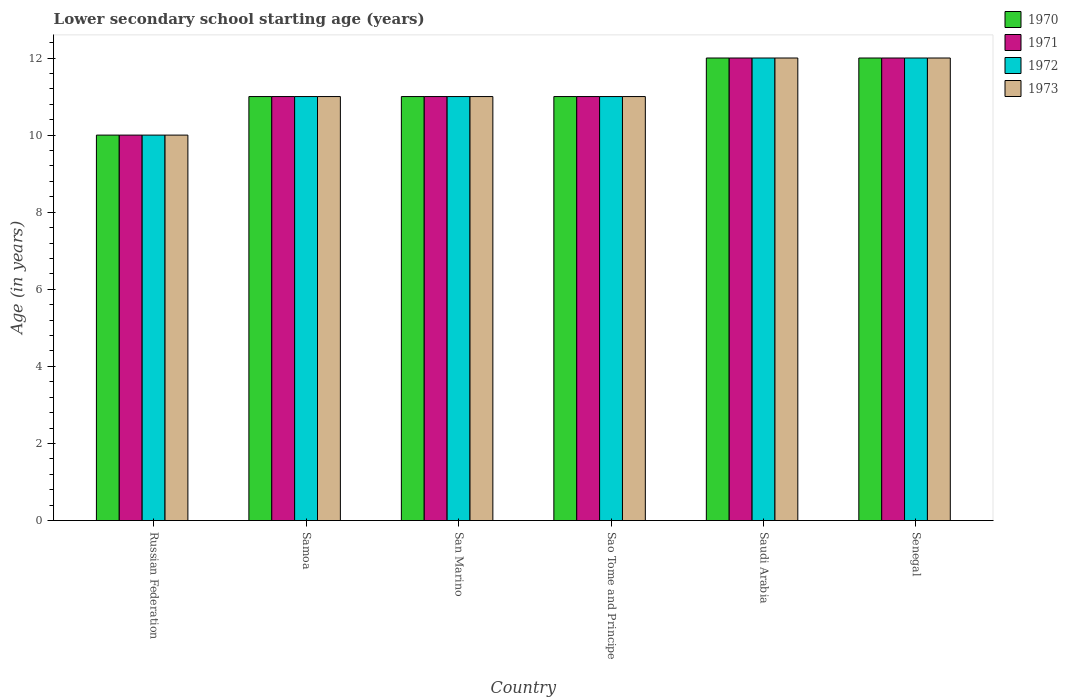How many groups of bars are there?
Your answer should be compact. 6. Are the number of bars per tick equal to the number of legend labels?
Your answer should be very brief. Yes. Are the number of bars on each tick of the X-axis equal?
Your answer should be compact. Yes. How many bars are there on the 2nd tick from the left?
Make the answer very short. 4. How many bars are there on the 1st tick from the right?
Ensure brevity in your answer.  4. What is the label of the 2nd group of bars from the left?
Provide a short and direct response. Samoa. In how many cases, is the number of bars for a given country not equal to the number of legend labels?
Ensure brevity in your answer.  0. What is the lower secondary school starting age of children in 1970 in Senegal?
Offer a terse response. 12. Across all countries, what is the minimum lower secondary school starting age of children in 1973?
Give a very brief answer. 10. In which country was the lower secondary school starting age of children in 1971 maximum?
Provide a succinct answer. Saudi Arabia. In which country was the lower secondary school starting age of children in 1970 minimum?
Your response must be concise. Russian Federation. What is the average lower secondary school starting age of children in 1972 per country?
Give a very brief answer. 11.17. In how many countries, is the lower secondary school starting age of children in 1972 greater than 6.8 years?
Offer a very short reply. 6. What is the ratio of the lower secondary school starting age of children in 1972 in Samoa to that in Sao Tome and Principe?
Your answer should be compact. 1. Is the lower secondary school starting age of children in 1970 in San Marino less than that in Saudi Arabia?
Make the answer very short. Yes. What is the difference between the highest and the second highest lower secondary school starting age of children in 1973?
Provide a succinct answer. -1. What is the difference between the highest and the lowest lower secondary school starting age of children in 1973?
Your response must be concise. 2. Is it the case that in every country, the sum of the lower secondary school starting age of children in 1971 and lower secondary school starting age of children in 1973 is greater than the sum of lower secondary school starting age of children in 1972 and lower secondary school starting age of children in 1970?
Your answer should be very brief. No. What does the 2nd bar from the left in Sao Tome and Principe represents?
Offer a terse response. 1971. What is the difference between two consecutive major ticks on the Y-axis?
Offer a terse response. 2. Does the graph contain any zero values?
Provide a short and direct response. No. How are the legend labels stacked?
Offer a very short reply. Vertical. What is the title of the graph?
Offer a terse response. Lower secondary school starting age (years). What is the label or title of the X-axis?
Offer a terse response. Country. What is the label or title of the Y-axis?
Ensure brevity in your answer.  Age (in years). What is the Age (in years) of 1970 in Russian Federation?
Your response must be concise. 10. What is the Age (in years) of 1970 in Samoa?
Keep it short and to the point. 11. What is the Age (in years) of 1972 in Samoa?
Your answer should be compact. 11. What is the Age (in years) of 1970 in San Marino?
Your answer should be very brief. 11. What is the Age (in years) of 1972 in San Marino?
Offer a terse response. 11. What is the Age (in years) in 1973 in San Marino?
Your answer should be compact. 11. What is the Age (in years) in 1970 in Sao Tome and Principe?
Make the answer very short. 11. What is the Age (in years) in 1971 in Sao Tome and Principe?
Provide a succinct answer. 11. What is the Age (in years) in 1972 in Sao Tome and Principe?
Offer a very short reply. 11. What is the Age (in years) of 1970 in Saudi Arabia?
Ensure brevity in your answer.  12. What is the Age (in years) of 1971 in Saudi Arabia?
Offer a terse response. 12. What is the Age (in years) in 1970 in Senegal?
Your answer should be compact. 12. What is the Age (in years) of 1971 in Senegal?
Your response must be concise. 12. What is the Age (in years) in 1972 in Senegal?
Give a very brief answer. 12. Across all countries, what is the maximum Age (in years) in 1970?
Offer a very short reply. 12. Across all countries, what is the maximum Age (in years) in 1972?
Provide a short and direct response. 12. Across all countries, what is the minimum Age (in years) in 1971?
Offer a very short reply. 10. What is the total Age (in years) of 1970 in the graph?
Your answer should be very brief. 67. What is the total Age (in years) in 1971 in the graph?
Make the answer very short. 67. What is the difference between the Age (in years) in 1970 in Russian Federation and that in Samoa?
Ensure brevity in your answer.  -1. What is the difference between the Age (in years) of 1972 in Russian Federation and that in Samoa?
Give a very brief answer. -1. What is the difference between the Age (in years) in 1973 in Russian Federation and that in Samoa?
Keep it short and to the point. -1. What is the difference between the Age (in years) in 1972 in Russian Federation and that in San Marino?
Offer a terse response. -1. What is the difference between the Age (in years) in 1970 in Russian Federation and that in Sao Tome and Principe?
Your answer should be very brief. -1. What is the difference between the Age (in years) in 1971 in Russian Federation and that in Saudi Arabia?
Offer a terse response. -2. What is the difference between the Age (in years) of 1972 in Russian Federation and that in Saudi Arabia?
Offer a terse response. -2. What is the difference between the Age (in years) of 1970 in Russian Federation and that in Senegal?
Make the answer very short. -2. What is the difference between the Age (in years) in 1971 in Samoa and that in San Marino?
Provide a short and direct response. 0. What is the difference between the Age (in years) of 1972 in Samoa and that in San Marino?
Make the answer very short. 0. What is the difference between the Age (in years) of 1972 in Samoa and that in Sao Tome and Principe?
Your response must be concise. 0. What is the difference between the Age (in years) in 1970 in Samoa and that in Saudi Arabia?
Your answer should be very brief. -1. What is the difference between the Age (in years) in 1971 in Samoa and that in Saudi Arabia?
Make the answer very short. -1. What is the difference between the Age (in years) in 1972 in Samoa and that in Saudi Arabia?
Your answer should be very brief. -1. What is the difference between the Age (in years) of 1971 in Samoa and that in Senegal?
Provide a short and direct response. -1. What is the difference between the Age (in years) in 1972 in Samoa and that in Senegal?
Offer a terse response. -1. What is the difference between the Age (in years) in 1973 in Samoa and that in Senegal?
Make the answer very short. -1. What is the difference between the Age (in years) in 1971 in San Marino and that in Sao Tome and Principe?
Provide a short and direct response. 0. What is the difference between the Age (in years) of 1973 in San Marino and that in Sao Tome and Principe?
Your answer should be compact. 0. What is the difference between the Age (in years) of 1971 in San Marino and that in Saudi Arabia?
Provide a short and direct response. -1. What is the difference between the Age (in years) in 1970 in San Marino and that in Senegal?
Give a very brief answer. -1. What is the difference between the Age (in years) in 1971 in San Marino and that in Senegal?
Your answer should be very brief. -1. What is the difference between the Age (in years) in 1973 in San Marino and that in Senegal?
Provide a short and direct response. -1. What is the difference between the Age (in years) of 1970 in Sao Tome and Principe and that in Senegal?
Offer a terse response. -1. What is the difference between the Age (in years) in 1971 in Sao Tome and Principe and that in Senegal?
Your answer should be very brief. -1. What is the difference between the Age (in years) of 1972 in Sao Tome and Principe and that in Senegal?
Offer a terse response. -1. What is the difference between the Age (in years) of 1970 in Saudi Arabia and that in Senegal?
Provide a short and direct response. 0. What is the difference between the Age (in years) of 1970 in Russian Federation and the Age (in years) of 1972 in Samoa?
Your response must be concise. -1. What is the difference between the Age (in years) of 1970 in Russian Federation and the Age (in years) of 1973 in Samoa?
Your answer should be compact. -1. What is the difference between the Age (in years) of 1972 in Russian Federation and the Age (in years) of 1973 in Samoa?
Your answer should be very brief. -1. What is the difference between the Age (in years) of 1970 in Russian Federation and the Age (in years) of 1971 in San Marino?
Your response must be concise. -1. What is the difference between the Age (in years) of 1970 in Russian Federation and the Age (in years) of 1973 in San Marino?
Your answer should be compact. -1. What is the difference between the Age (in years) in 1970 in Russian Federation and the Age (in years) in 1971 in Sao Tome and Principe?
Provide a succinct answer. -1. What is the difference between the Age (in years) of 1970 in Russian Federation and the Age (in years) of 1973 in Sao Tome and Principe?
Your answer should be compact. -1. What is the difference between the Age (in years) in 1971 in Russian Federation and the Age (in years) in 1973 in Sao Tome and Principe?
Give a very brief answer. -1. What is the difference between the Age (in years) in 1970 in Russian Federation and the Age (in years) in 1971 in Saudi Arabia?
Ensure brevity in your answer.  -2. What is the difference between the Age (in years) of 1970 in Russian Federation and the Age (in years) of 1972 in Saudi Arabia?
Offer a terse response. -2. What is the difference between the Age (in years) in 1971 in Russian Federation and the Age (in years) in 1972 in Saudi Arabia?
Provide a short and direct response. -2. What is the difference between the Age (in years) in 1971 in Russian Federation and the Age (in years) in 1973 in Saudi Arabia?
Keep it short and to the point. -2. What is the difference between the Age (in years) in 1970 in Russian Federation and the Age (in years) in 1971 in Senegal?
Provide a short and direct response. -2. What is the difference between the Age (in years) of 1970 in Russian Federation and the Age (in years) of 1972 in Senegal?
Your response must be concise. -2. What is the difference between the Age (in years) of 1972 in Russian Federation and the Age (in years) of 1973 in Senegal?
Keep it short and to the point. -2. What is the difference between the Age (in years) in 1970 in Samoa and the Age (in years) in 1972 in San Marino?
Your response must be concise. 0. What is the difference between the Age (in years) of 1970 in Samoa and the Age (in years) of 1973 in San Marino?
Your answer should be compact. 0. What is the difference between the Age (in years) in 1971 in Samoa and the Age (in years) in 1972 in San Marino?
Your answer should be compact. 0. What is the difference between the Age (in years) of 1970 in Samoa and the Age (in years) of 1971 in Sao Tome and Principe?
Offer a terse response. 0. What is the difference between the Age (in years) of 1972 in Samoa and the Age (in years) of 1973 in Saudi Arabia?
Your answer should be very brief. -1. What is the difference between the Age (in years) of 1970 in Samoa and the Age (in years) of 1972 in Senegal?
Give a very brief answer. -1. What is the difference between the Age (in years) of 1971 in Samoa and the Age (in years) of 1973 in Senegal?
Your response must be concise. -1. What is the difference between the Age (in years) of 1970 in San Marino and the Age (in years) of 1971 in Sao Tome and Principe?
Your response must be concise. 0. What is the difference between the Age (in years) in 1970 in San Marino and the Age (in years) in 1972 in Sao Tome and Principe?
Ensure brevity in your answer.  0. What is the difference between the Age (in years) of 1970 in San Marino and the Age (in years) of 1973 in Sao Tome and Principe?
Make the answer very short. 0. What is the difference between the Age (in years) of 1971 in San Marino and the Age (in years) of 1972 in Sao Tome and Principe?
Offer a terse response. 0. What is the difference between the Age (in years) in 1972 in San Marino and the Age (in years) in 1973 in Sao Tome and Principe?
Offer a very short reply. 0. What is the difference between the Age (in years) of 1970 in San Marino and the Age (in years) of 1971 in Saudi Arabia?
Keep it short and to the point. -1. What is the difference between the Age (in years) of 1970 in San Marino and the Age (in years) of 1972 in Saudi Arabia?
Keep it short and to the point. -1. What is the difference between the Age (in years) of 1970 in San Marino and the Age (in years) of 1973 in Saudi Arabia?
Provide a succinct answer. -1. What is the difference between the Age (in years) of 1970 in San Marino and the Age (in years) of 1971 in Senegal?
Your answer should be very brief. -1. What is the difference between the Age (in years) of 1970 in San Marino and the Age (in years) of 1972 in Senegal?
Your response must be concise. -1. What is the difference between the Age (in years) of 1971 in San Marino and the Age (in years) of 1973 in Senegal?
Your response must be concise. -1. What is the difference between the Age (in years) of 1972 in San Marino and the Age (in years) of 1973 in Senegal?
Ensure brevity in your answer.  -1. What is the difference between the Age (in years) of 1970 in Sao Tome and Principe and the Age (in years) of 1971 in Saudi Arabia?
Give a very brief answer. -1. What is the difference between the Age (in years) of 1970 in Sao Tome and Principe and the Age (in years) of 1972 in Saudi Arabia?
Your response must be concise. -1. What is the difference between the Age (in years) in 1970 in Sao Tome and Principe and the Age (in years) in 1973 in Saudi Arabia?
Your answer should be very brief. -1. What is the difference between the Age (in years) in 1971 in Sao Tome and Principe and the Age (in years) in 1972 in Saudi Arabia?
Provide a short and direct response. -1. What is the difference between the Age (in years) of 1971 in Sao Tome and Principe and the Age (in years) of 1973 in Saudi Arabia?
Provide a succinct answer. -1. What is the difference between the Age (in years) of 1970 in Sao Tome and Principe and the Age (in years) of 1971 in Senegal?
Offer a terse response. -1. What is the difference between the Age (in years) in 1970 in Sao Tome and Principe and the Age (in years) in 1973 in Senegal?
Your response must be concise. -1. What is the difference between the Age (in years) of 1970 in Saudi Arabia and the Age (in years) of 1972 in Senegal?
Provide a succinct answer. 0. What is the difference between the Age (in years) of 1971 in Saudi Arabia and the Age (in years) of 1972 in Senegal?
Provide a succinct answer. 0. What is the difference between the Age (in years) in 1972 in Saudi Arabia and the Age (in years) in 1973 in Senegal?
Your answer should be compact. 0. What is the average Age (in years) in 1970 per country?
Your answer should be very brief. 11.17. What is the average Age (in years) in 1971 per country?
Provide a short and direct response. 11.17. What is the average Age (in years) of 1972 per country?
Provide a short and direct response. 11.17. What is the average Age (in years) in 1973 per country?
Offer a very short reply. 11.17. What is the difference between the Age (in years) of 1972 and Age (in years) of 1973 in Russian Federation?
Keep it short and to the point. 0. What is the difference between the Age (in years) in 1970 and Age (in years) in 1973 in Samoa?
Your response must be concise. 0. What is the difference between the Age (in years) in 1970 and Age (in years) in 1971 in San Marino?
Make the answer very short. 0. What is the difference between the Age (in years) in 1970 and Age (in years) in 1972 in San Marino?
Your response must be concise. 0. What is the difference between the Age (in years) of 1970 and Age (in years) of 1973 in San Marino?
Your response must be concise. 0. What is the difference between the Age (in years) of 1971 and Age (in years) of 1972 in San Marino?
Offer a terse response. 0. What is the difference between the Age (in years) in 1972 and Age (in years) in 1973 in San Marino?
Your answer should be compact. 0. What is the difference between the Age (in years) in 1970 and Age (in years) in 1971 in Sao Tome and Principe?
Ensure brevity in your answer.  0. What is the difference between the Age (in years) in 1970 and Age (in years) in 1972 in Sao Tome and Principe?
Give a very brief answer. 0. What is the difference between the Age (in years) of 1972 and Age (in years) of 1973 in Sao Tome and Principe?
Keep it short and to the point. 0. What is the difference between the Age (in years) of 1970 and Age (in years) of 1971 in Saudi Arabia?
Provide a short and direct response. 0. What is the difference between the Age (in years) of 1970 and Age (in years) of 1972 in Saudi Arabia?
Offer a terse response. 0. What is the difference between the Age (in years) in 1970 and Age (in years) in 1973 in Saudi Arabia?
Your answer should be compact. 0. What is the difference between the Age (in years) in 1971 and Age (in years) in 1972 in Saudi Arabia?
Offer a very short reply. 0. What is the difference between the Age (in years) in 1972 and Age (in years) in 1973 in Saudi Arabia?
Ensure brevity in your answer.  0. What is the difference between the Age (in years) in 1970 and Age (in years) in 1971 in Senegal?
Ensure brevity in your answer.  0. What is the difference between the Age (in years) of 1970 and Age (in years) of 1972 in Senegal?
Provide a short and direct response. 0. What is the difference between the Age (in years) of 1971 and Age (in years) of 1972 in Senegal?
Ensure brevity in your answer.  0. What is the difference between the Age (in years) of 1971 and Age (in years) of 1973 in Senegal?
Ensure brevity in your answer.  0. What is the difference between the Age (in years) in 1972 and Age (in years) in 1973 in Senegal?
Give a very brief answer. 0. What is the ratio of the Age (in years) of 1970 in Russian Federation to that in Samoa?
Your answer should be very brief. 0.91. What is the ratio of the Age (in years) in 1972 in Russian Federation to that in Samoa?
Make the answer very short. 0.91. What is the ratio of the Age (in years) of 1970 in Russian Federation to that in San Marino?
Your answer should be very brief. 0.91. What is the ratio of the Age (in years) in 1971 in Russian Federation to that in San Marino?
Keep it short and to the point. 0.91. What is the ratio of the Age (in years) of 1970 in Russian Federation to that in Sao Tome and Principe?
Your answer should be compact. 0.91. What is the ratio of the Age (in years) in 1973 in Russian Federation to that in Sao Tome and Principe?
Provide a succinct answer. 0.91. What is the ratio of the Age (in years) in 1971 in Russian Federation to that in Saudi Arabia?
Offer a terse response. 0.83. What is the ratio of the Age (in years) in 1973 in Russian Federation to that in Saudi Arabia?
Offer a terse response. 0.83. What is the ratio of the Age (in years) in 1971 in Russian Federation to that in Senegal?
Ensure brevity in your answer.  0.83. What is the ratio of the Age (in years) of 1972 in Russian Federation to that in Senegal?
Ensure brevity in your answer.  0.83. What is the ratio of the Age (in years) of 1972 in Samoa to that in San Marino?
Provide a succinct answer. 1. What is the ratio of the Age (in years) of 1970 in Samoa to that in Sao Tome and Principe?
Your response must be concise. 1. What is the ratio of the Age (in years) in 1971 in Samoa to that in Sao Tome and Principe?
Provide a short and direct response. 1. What is the ratio of the Age (in years) in 1973 in Samoa to that in Sao Tome and Principe?
Ensure brevity in your answer.  1. What is the ratio of the Age (in years) of 1972 in Samoa to that in Saudi Arabia?
Your answer should be compact. 0.92. What is the ratio of the Age (in years) of 1973 in Samoa to that in Saudi Arabia?
Keep it short and to the point. 0.92. What is the ratio of the Age (in years) in 1970 in Samoa to that in Senegal?
Offer a very short reply. 0.92. What is the ratio of the Age (in years) of 1972 in Samoa to that in Senegal?
Your answer should be compact. 0.92. What is the ratio of the Age (in years) in 1970 in San Marino to that in Sao Tome and Principe?
Your response must be concise. 1. What is the ratio of the Age (in years) in 1971 in San Marino to that in Sao Tome and Principe?
Make the answer very short. 1. What is the ratio of the Age (in years) in 1973 in San Marino to that in Sao Tome and Principe?
Your answer should be compact. 1. What is the ratio of the Age (in years) in 1970 in San Marino to that in Saudi Arabia?
Your answer should be very brief. 0.92. What is the ratio of the Age (in years) of 1973 in San Marino to that in Saudi Arabia?
Your answer should be very brief. 0.92. What is the ratio of the Age (in years) in 1970 in San Marino to that in Senegal?
Give a very brief answer. 0.92. What is the ratio of the Age (in years) in 1971 in San Marino to that in Senegal?
Offer a terse response. 0.92. What is the ratio of the Age (in years) of 1972 in San Marino to that in Senegal?
Offer a very short reply. 0.92. What is the ratio of the Age (in years) of 1970 in Sao Tome and Principe to that in Saudi Arabia?
Your response must be concise. 0.92. What is the ratio of the Age (in years) in 1972 in Sao Tome and Principe to that in Saudi Arabia?
Offer a terse response. 0.92. What is the ratio of the Age (in years) in 1971 in Sao Tome and Principe to that in Senegal?
Provide a succinct answer. 0.92. What is the ratio of the Age (in years) in 1972 in Sao Tome and Principe to that in Senegal?
Provide a succinct answer. 0.92. What is the ratio of the Age (in years) in 1973 in Sao Tome and Principe to that in Senegal?
Offer a very short reply. 0.92. What is the ratio of the Age (in years) in 1970 in Saudi Arabia to that in Senegal?
Your answer should be very brief. 1. What is the ratio of the Age (in years) in 1972 in Saudi Arabia to that in Senegal?
Provide a succinct answer. 1. What is the difference between the highest and the second highest Age (in years) in 1970?
Your answer should be compact. 0. What is the difference between the highest and the lowest Age (in years) of 1972?
Offer a very short reply. 2. 